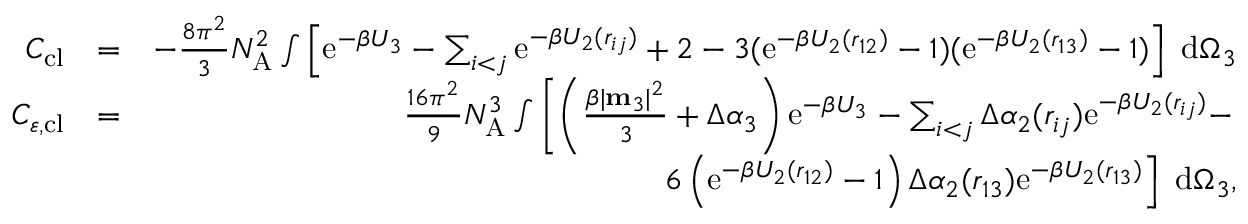Convert formula to latex. <formula><loc_0><loc_0><loc_500><loc_500>\begin{array} { r l r } { C _ { c l } } & { = } & { - \frac { 8 \pi ^ { 2 } } { 3 } N _ { A } ^ { 2 } \int \left [ e ^ { - \beta U _ { 3 } } - \sum _ { i < j } e ^ { - \beta U _ { 2 } ( r _ { i j } ) } + 2 - 3 ( e ^ { - \beta U _ { 2 } ( r _ { 1 2 } ) } - 1 ) ( e ^ { - \beta U _ { 2 } ( r _ { 1 3 } ) } - 1 ) \right ] d \Omega _ { 3 } } \\ { C _ { \varepsilon , c l } } & { = } & { \frac { 1 6 \pi ^ { 2 } } { 9 } N _ { A } ^ { 3 } \int \left [ \left ( \frac { \beta | m _ { 3 } | ^ { 2 } } { 3 } + \Delta \alpha _ { 3 } \right ) e ^ { - \beta U _ { 3 } } - \sum _ { i < j } \Delta \alpha _ { 2 } ( r _ { i j } ) e ^ { - \beta U _ { 2 } ( r _ { i j } ) } - } \\ & { 6 \left ( e ^ { - \beta U _ { 2 } ( r _ { 1 2 } ) } - 1 \right ) \Delta \alpha _ { 2 } ( r _ { 1 3 } ) e ^ { - \beta U _ { 2 } ( r _ { 1 3 } ) } \right ] d \Omega _ { 3 } , } \end{array}</formula> 